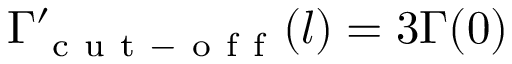<formula> <loc_0><loc_0><loc_500><loc_500>\Gamma _ { c u t - o f f } ^ { \prime } ( l ) = 3 \Gamma ( 0 )</formula> 